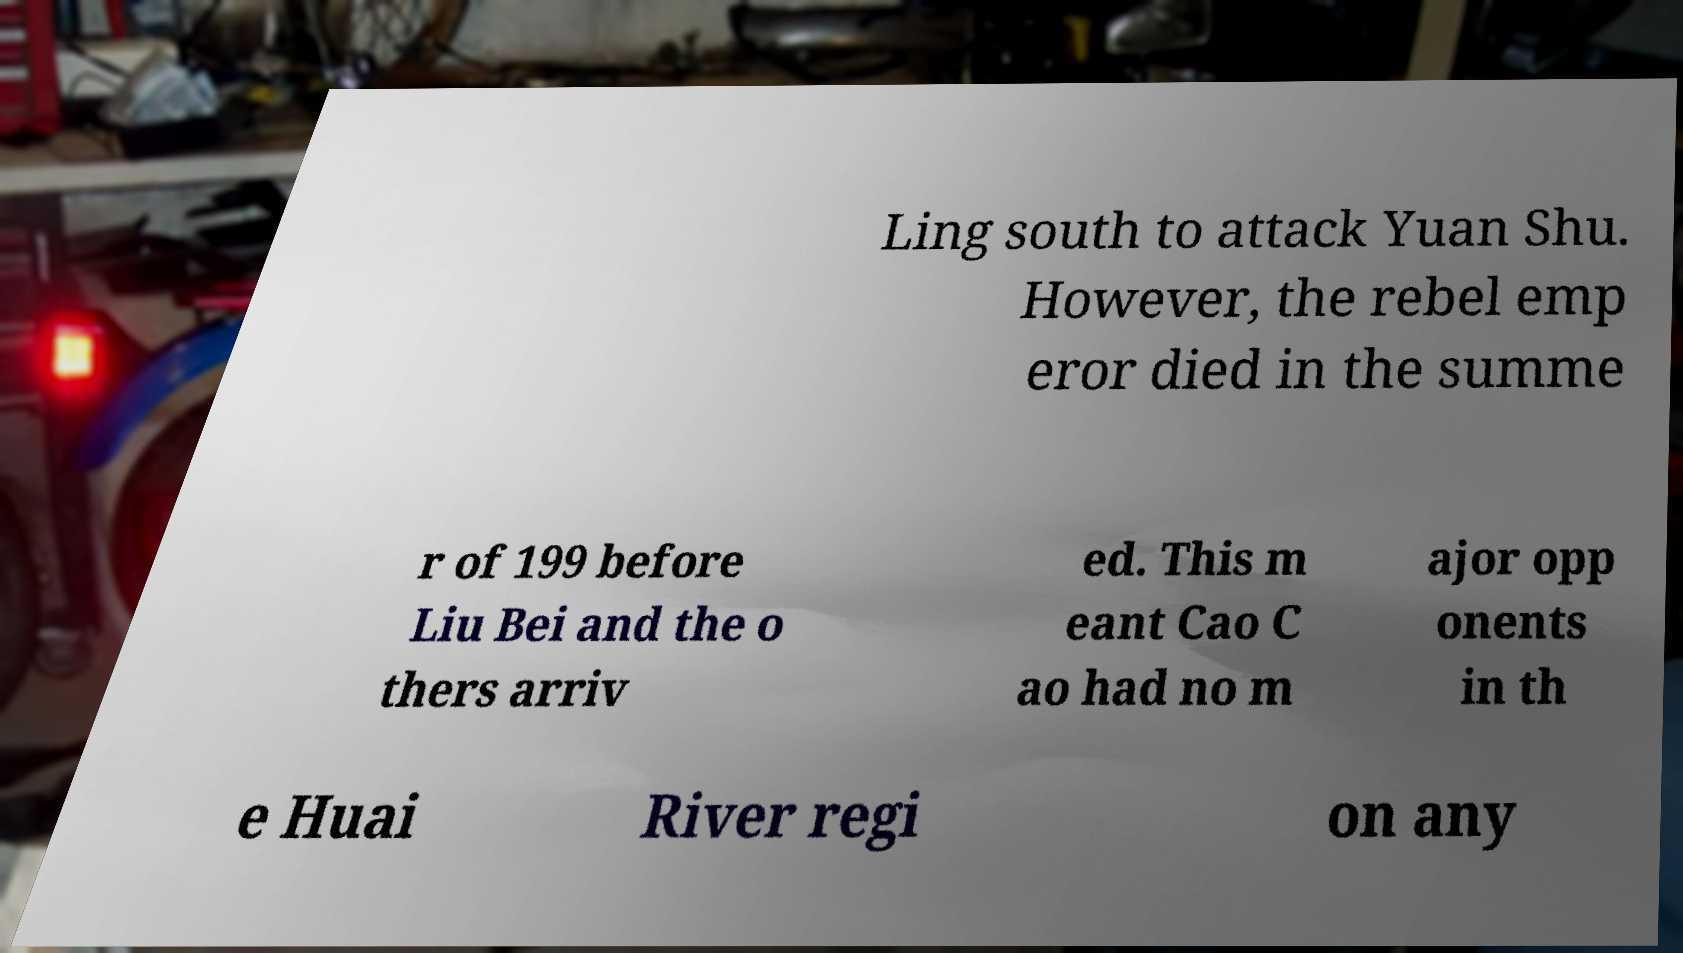Can you accurately transcribe the text from the provided image for me? Ling south to attack Yuan Shu. However, the rebel emp eror died in the summe r of 199 before Liu Bei and the o thers arriv ed. This m eant Cao C ao had no m ajor opp onents in th e Huai River regi on any 